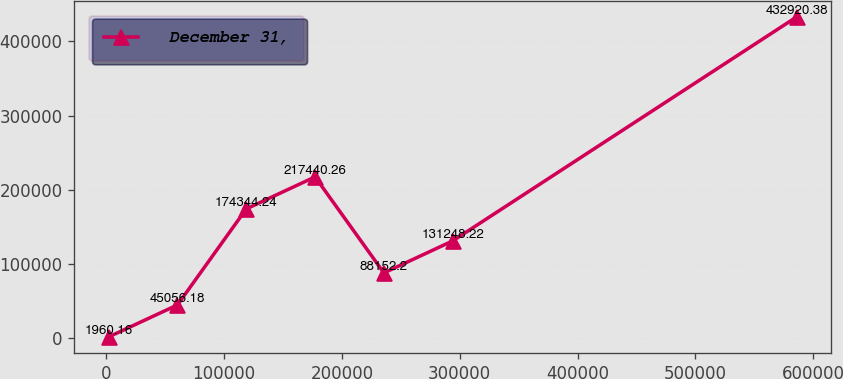<chart> <loc_0><loc_0><loc_500><loc_500><line_chart><ecel><fcel>December 31,<nl><fcel>2032.15<fcel>1960.16<nl><fcel>60431.4<fcel>45056.2<nl><fcel>118831<fcel>174344<nl><fcel>177230<fcel>217440<nl><fcel>235629<fcel>88152.2<nl><fcel>294028<fcel>131248<nl><fcel>586025<fcel>432920<nl></chart> 